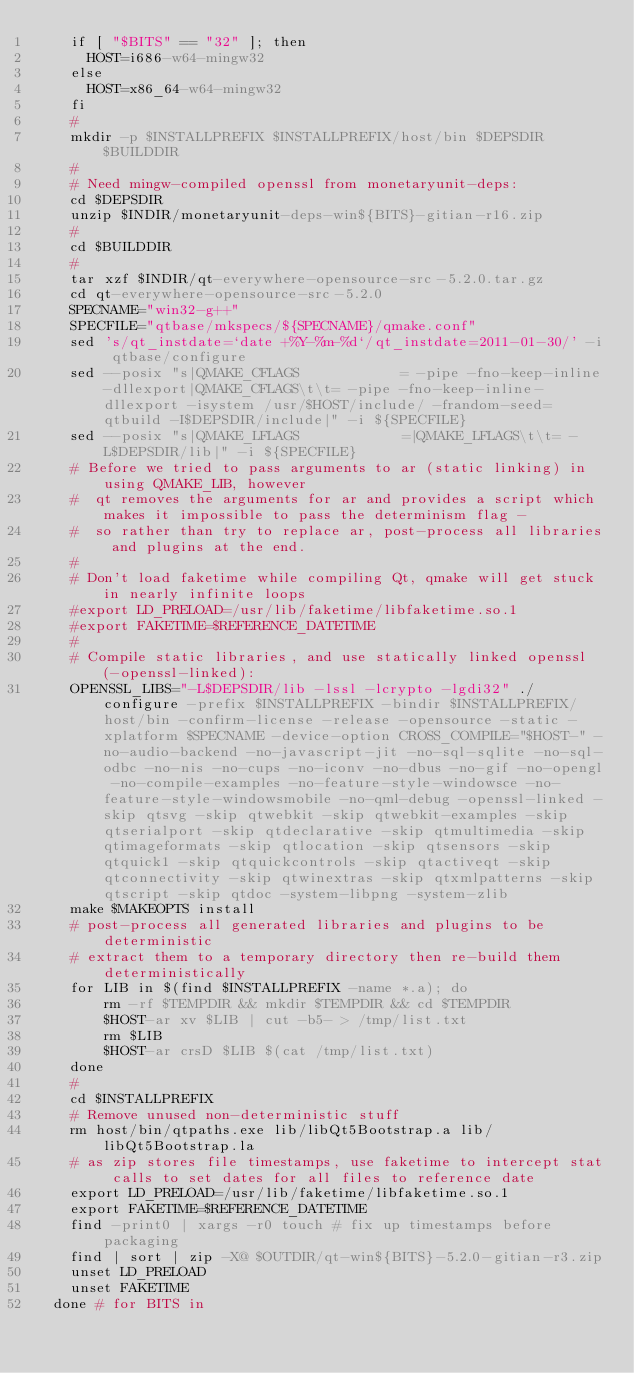<code> <loc_0><loc_0><loc_500><loc_500><_YAML_>    if [ "$BITS" == "32" ]; then
      HOST=i686-w64-mingw32
    else
      HOST=x86_64-w64-mingw32
    fi
    #
    mkdir -p $INSTALLPREFIX $INSTALLPREFIX/host/bin $DEPSDIR $BUILDDIR
    #
    # Need mingw-compiled openssl from monetaryunit-deps:
    cd $DEPSDIR
    unzip $INDIR/monetaryunit-deps-win${BITS}-gitian-r16.zip
    #
    cd $BUILDDIR
    #
    tar xzf $INDIR/qt-everywhere-opensource-src-5.2.0.tar.gz
    cd qt-everywhere-opensource-src-5.2.0
    SPECNAME="win32-g++"
    SPECFILE="qtbase/mkspecs/${SPECNAME}/qmake.conf"
    sed 's/qt_instdate=`date +%Y-%m-%d`/qt_instdate=2011-01-30/' -i qtbase/configure
    sed --posix "s|QMAKE_CFLAGS            = -pipe -fno-keep-inline-dllexport|QMAKE_CFLAGS\t\t= -pipe -fno-keep-inline-dllexport -isystem /usr/$HOST/include/ -frandom-seed=qtbuild -I$DEPSDIR/include|" -i ${SPECFILE}
    sed --posix "s|QMAKE_LFLAGS            =|QMAKE_LFLAGS\t\t= -L$DEPSDIR/lib|" -i ${SPECFILE}
    # Before we tried to pass arguments to ar (static linking) in using QMAKE_LIB, however
    #  qt removes the arguments for ar and provides a script which makes it impossible to pass the determinism flag -
    #  so rather than try to replace ar, post-process all libraries and plugins at the end.
    #
    # Don't load faketime while compiling Qt, qmake will get stuck in nearly infinite loops
    #export LD_PRELOAD=/usr/lib/faketime/libfaketime.so.1
    #export FAKETIME=$REFERENCE_DATETIME
    #
    # Compile static libraries, and use statically linked openssl (-openssl-linked):
    OPENSSL_LIBS="-L$DEPSDIR/lib -lssl -lcrypto -lgdi32" ./configure -prefix $INSTALLPREFIX -bindir $INSTALLPREFIX/host/bin -confirm-license -release -opensource -static -xplatform $SPECNAME -device-option CROSS_COMPILE="$HOST-" -no-audio-backend -no-javascript-jit -no-sql-sqlite -no-sql-odbc -no-nis -no-cups -no-iconv -no-dbus -no-gif -no-opengl -no-compile-examples -no-feature-style-windowsce -no-feature-style-windowsmobile -no-qml-debug -openssl-linked -skip qtsvg -skip qtwebkit -skip qtwebkit-examples -skip qtserialport -skip qtdeclarative -skip qtmultimedia -skip qtimageformats -skip qtlocation -skip qtsensors -skip qtquick1 -skip qtquickcontrols -skip qtactiveqt -skip qtconnectivity -skip qtwinextras -skip qtxmlpatterns -skip qtscript -skip qtdoc -system-libpng -system-zlib
    make $MAKEOPTS install
    # post-process all generated libraries and plugins to be deterministic
    # extract them to a temporary directory then re-build them deterministically
    for LIB in $(find $INSTALLPREFIX -name *.a); do
        rm -rf $TEMPDIR && mkdir $TEMPDIR && cd $TEMPDIR
        $HOST-ar xv $LIB | cut -b5- > /tmp/list.txt
        rm $LIB
        $HOST-ar crsD $LIB $(cat /tmp/list.txt)
    done
    #
    cd $INSTALLPREFIX
    # Remove unused non-deterministic stuff
    rm host/bin/qtpaths.exe lib/libQt5Bootstrap.a lib/libQt5Bootstrap.la
    # as zip stores file timestamps, use faketime to intercept stat calls to set dates for all files to reference date
    export LD_PRELOAD=/usr/lib/faketime/libfaketime.so.1
    export FAKETIME=$REFERENCE_DATETIME
    find -print0 | xargs -r0 touch # fix up timestamps before packaging
    find | sort | zip -X@ $OUTDIR/qt-win${BITS}-5.2.0-gitian-r3.zip
    unset LD_PRELOAD
    unset FAKETIME
  done # for BITS in
</code> 